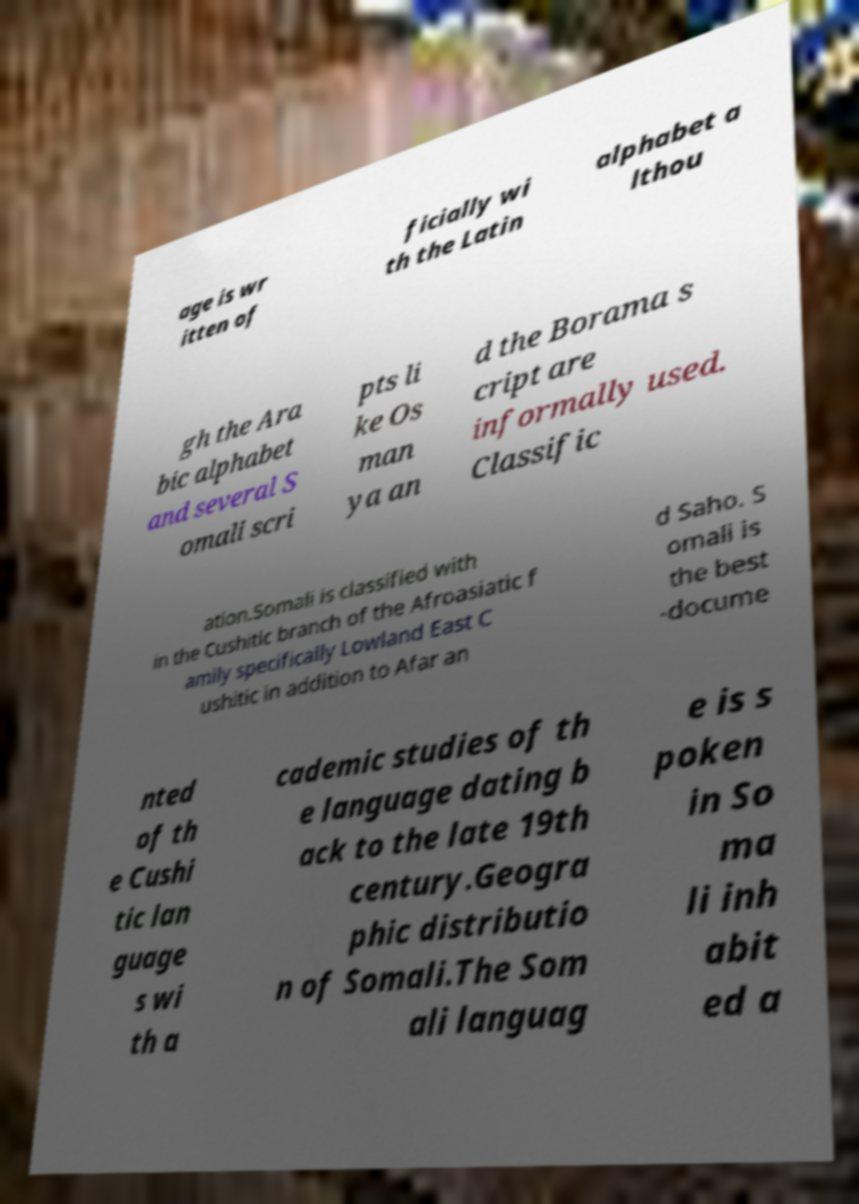I need the written content from this picture converted into text. Can you do that? age is wr itten of ficially wi th the Latin alphabet a lthou gh the Ara bic alphabet and several S omali scri pts li ke Os man ya an d the Borama s cript are informally used. Classific ation.Somali is classified with in the Cushitic branch of the Afroasiatic f amily specifically Lowland East C ushitic in addition to Afar an d Saho. S omali is the best -docume nted of th e Cushi tic lan guage s wi th a cademic studies of th e language dating b ack to the late 19th century.Geogra phic distributio n of Somali.The Som ali languag e is s poken in So ma li inh abit ed a 